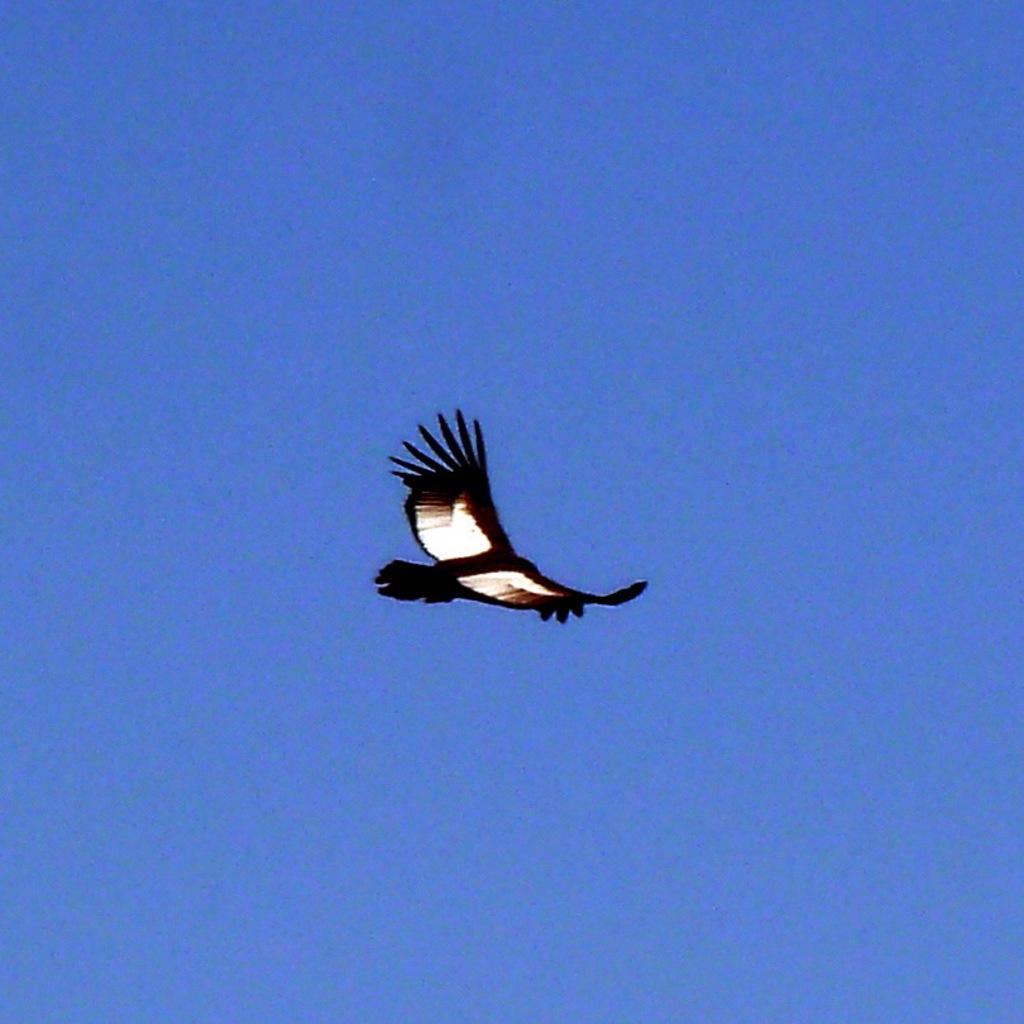What animal can be seen in the image? There is a bird in the image. What is the bird doing in the image? The bird is flying in the air. What can be seen in the background of the image? The sky is visible in the image. What is the color of the sky in the image? The color of the sky is blue. What type of flower is being held by the bird in the image? There is no flower present in the image, and the bird is not holding anything. 